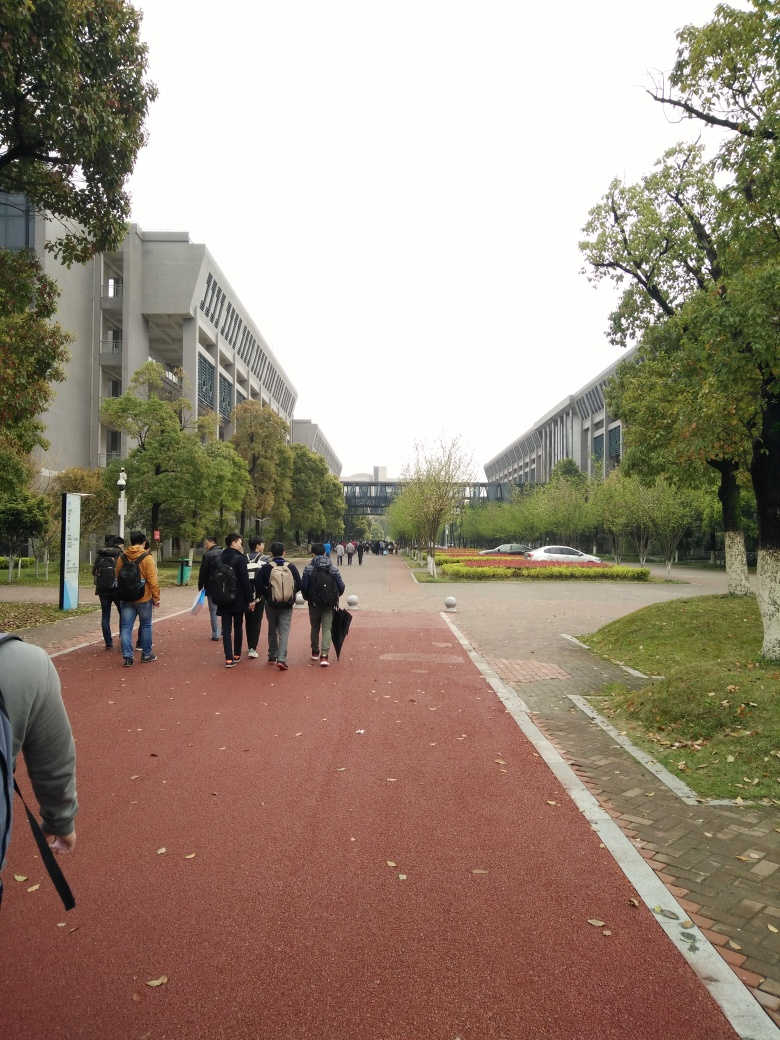Can you describe the atmosphere of the location shown in the image? The image depicts a serene university campus on what appears to be a quiet, overcast day. The students are dressed comfortably, suggesting a casual and relaxed environment. The overcast sky, combined with the natural greenery lining the walkway, imparts a calm and tranquil atmosphere to the location. 